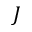<formula> <loc_0><loc_0><loc_500><loc_500>J</formula> 